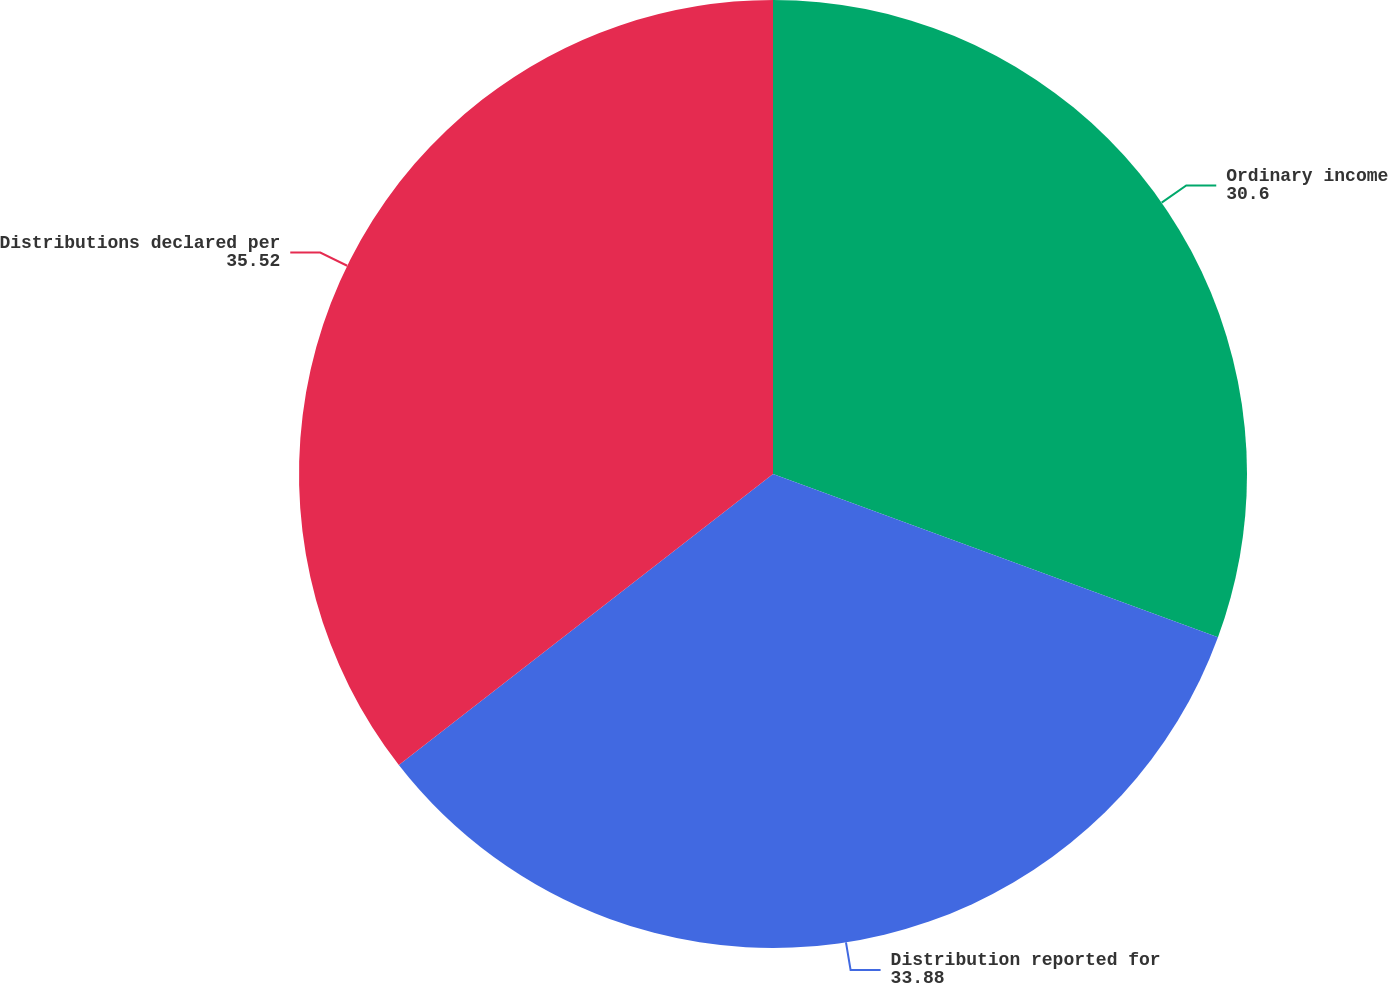Convert chart to OTSL. <chart><loc_0><loc_0><loc_500><loc_500><pie_chart><fcel>Ordinary income<fcel>Distribution reported for<fcel>Distributions declared per<nl><fcel>30.6%<fcel>33.88%<fcel>35.52%<nl></chart> 